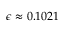<formula> <loc_0><loc_0><loc_500><loc_500>\epsilon \approx 0 . 1 0 2 1</formula> 